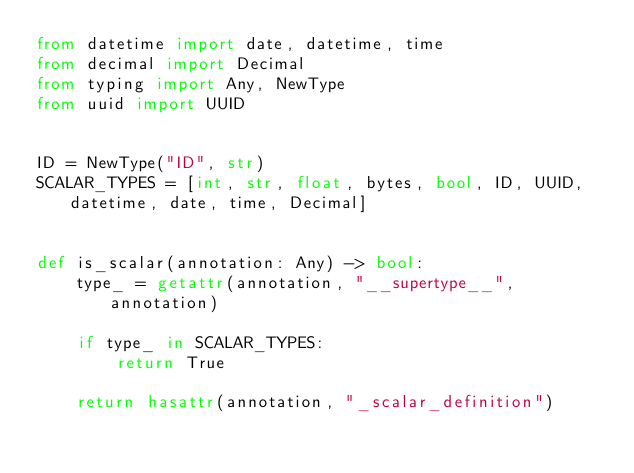<code> <loc_0><loc_0><loc_500><loc_500><_Python_>from datetime import date, datetime, time
from decimal import Decimal
from typing import Any, NewType
from uuid import UUID


ID = NewType("ID", str)
SCALAR_TYPES = [int, str, float, bytes, bool, ID, UUID, datetime, date, time, Decimal]


def is_scalar(annotation: Any) -> bool:
    type_ = getattr(annotation, "__supertype__", annotation)

    if type_ in SCALAR_TYPES:
        return True

    return hasattr(annotation, "_scalar_definition")
</code> 